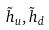Convert formula to latex. <formula><loc_0><loc_0><loc_500><loc_500>\tilde { h } _ { u } , \tilde { h } _ { d }</formula> 